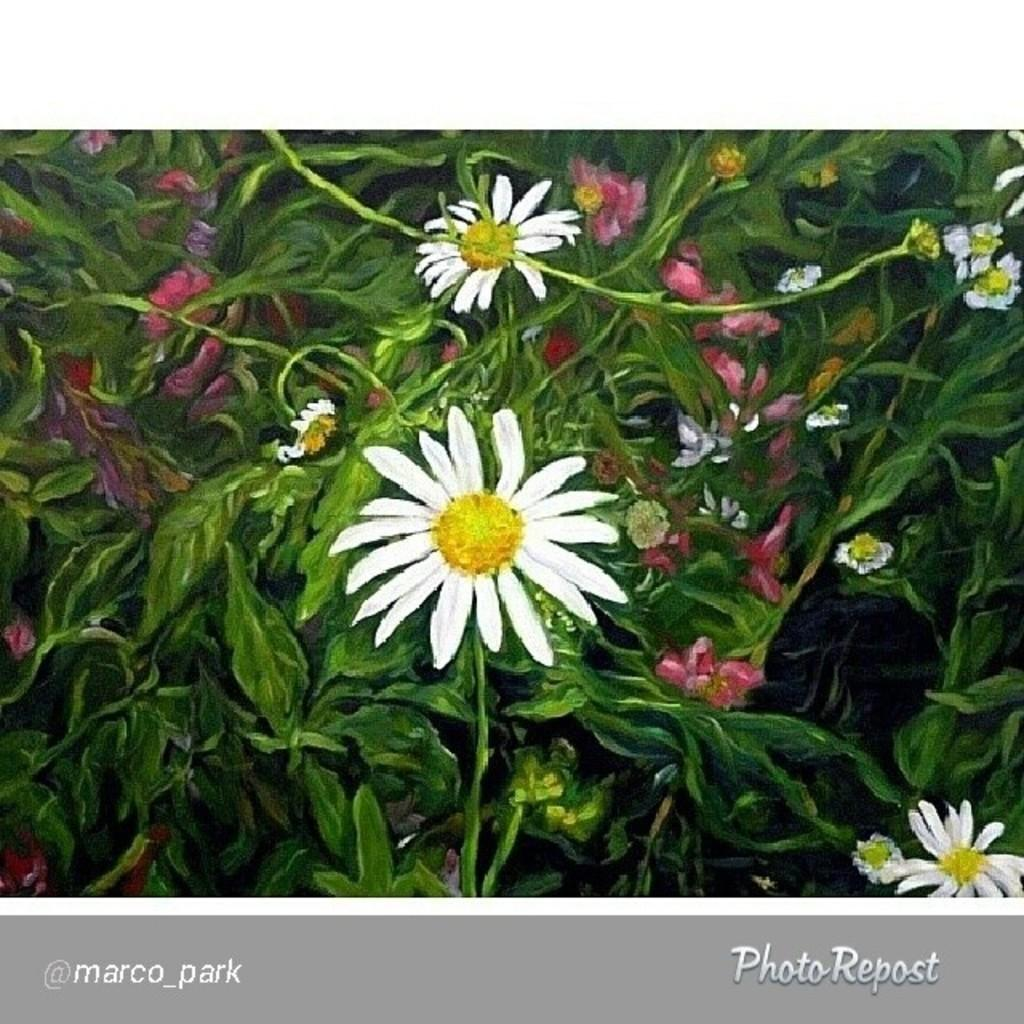What type of plants are in the image? The image contains flower plants. Can you describe any additional features of the image? There is a watermark at the bottom of the image. What type of test can be seen being conducted in the image? There is no test being conducted in the image; it contains flower plants and a watermark. Can you provide a list of the structures visible in the image? There are no structures visible in the image, only flower plants and a watermark. 